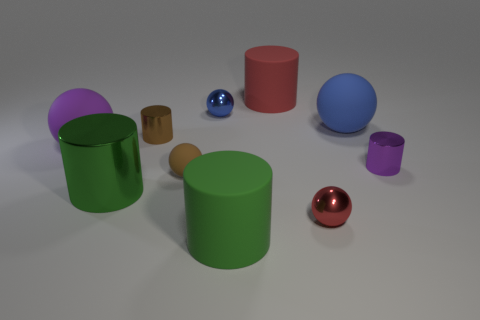Are there any patterns or consistencies in the arrangement of the objects? The objects are scattered with no apparent pattern. However, objects of similar shapes are not clustered together, indicating a random distribution. 